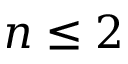<formula> <loc_0><loc_0><loc_500><loc_500>n \leq 2</formula> 